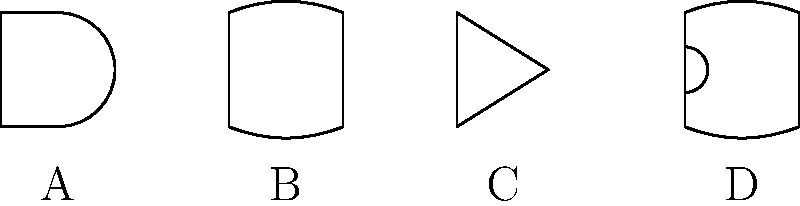In the context of digital circuit design, imagine you're composing a song about logic gates. Each gate represents a different musical element. Identify the logic gates A, B, C, and D shown in the schematic above. Which one would you use to create a harmonious blend of two different melodies, similar to how Loretta Heywood might layer her vocals? Let's break down the identification of each logic gate and relate it to our musical analogy:

1. Gate A: This is an AND gate. In music, it could represent two simultaneous notes that must be played together to produce a specific harmony.

2. Gate B: This is an OR gate. Musically, it might represent a choice between two different melodic lines.

3. Gate C: This is a NOT gate (inverter). In music, this could be thought of as changing a major chord to a minor chord, or vice versa.

4. Gate D: This is an XOR (Exclusive OR) gate. The XOR gate is unique because it produces an output when inputs are different, but not when they're the same.

In the context of blending two different melodies, the XOR gate (D) is the most suitable choice. Here's why:

- The XOR gate produces an output when its inputs are different, which is analogous to how two distinct melodies can be layered to create a rich, harmonious sound.
- When the inputs are the same, the XOR gate doesn't produce an output, which could represent moments in a song where melodies align or converge.
- This behavior is similar to how Loretta Heywood might layer her vocals, creating interesting harmonies when the vocal lines differ, but allowing them to merge seamlessly when they align.

Therefore, the XOR gate (D) would be the best choice for creating a harmonious blend of two different melodies in our musical analogy of logic gates.
Answer: XOR gate (D) 